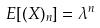<formula> <loc_0><loc_0><loc_500><loc_500>E [ ( X ) _ { n } ] = \lambda ^ { n }</formula> 